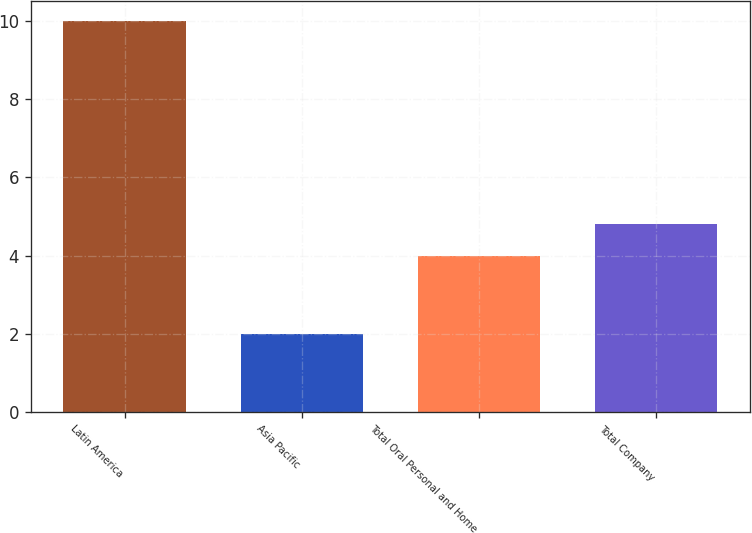Convert chart. <chart><loc_0><loc_0><loc_500><loc_500><bar_chart><fcel>Latin America<fcel>Asia Pacific<fcel>Total Oral Personal and Home<fcel>Total Company<nl><fcel>10<fcel>2<fcel>4<fcel>4.8<nl></chart> 